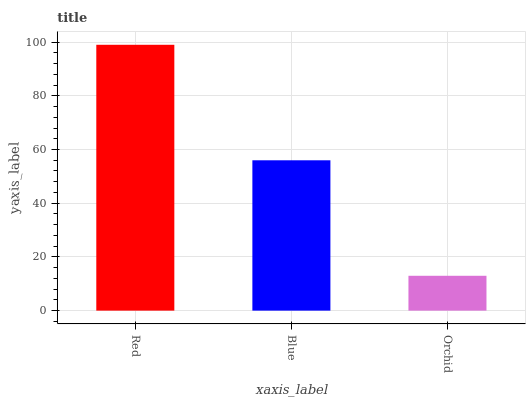Is Orchid the minimum?
Answer yes or no. Yes. Is Red the maximum?
Answer yes or no. Yes. Is Blue the minimum?
Answer yes or no. No. Is Blue the maximum?
Answer yes or no. No. Is Red greater than Blue?
Answer yes or no. Yes. Is Blue less than Red?
Answer yes or no. Yes. Is Blue greater than Red?
Answer yes or no. No. Is Red less than Blue?
Answer yes or no. No. Is Blue the high median?
Answer yes or no. Yes. Is Blue the low median?
Answer yes or no. Yes. Is Orchid the high median?
Answer yes or no. No. Is Red the low median?
Answer yes or no. No. 